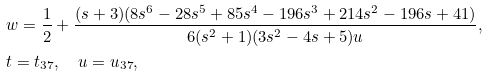<formula> <loc_0><loc_0><loc_500><loc_500>& w = \frac { 1 } { 2 } + \frac { ( s + 3 ) ( 8 s ^ { 6 } - 2 8 s ^ { 5 } + 8 5 s ^ { 4 } - 1 9 6 s ^ { 3 } + 2 1 4 s ^ { 2 } - 1 9 6 s + 4 1 ) } { 6 ( s ^ { 2 } + 1 ) ( 3 s ^ { 2 } - 4 s + 5 ) u } , \\ & t = t _ { 3 7 } , \quad u = u _ { 3 7 } ,</formula> 